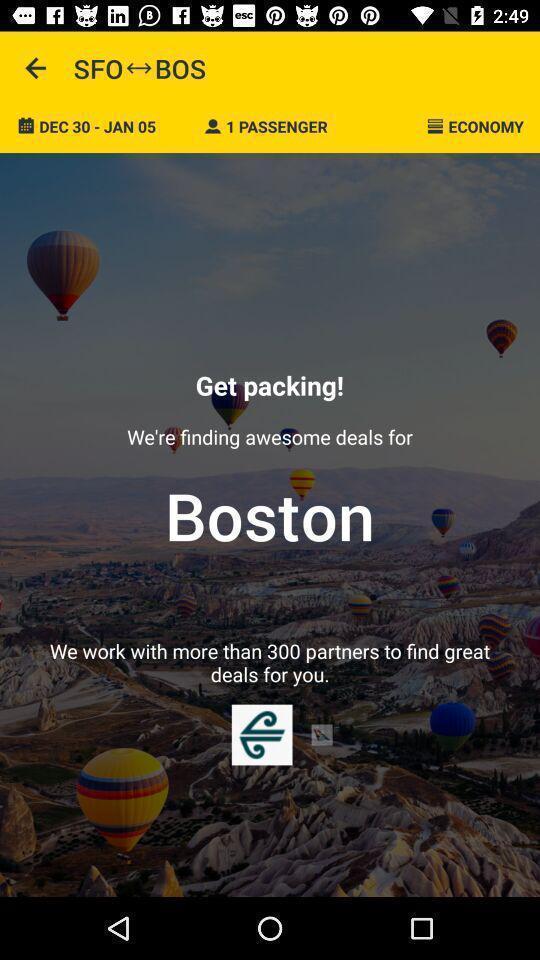What can you discern from this picture? Welcome page. 